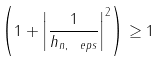<formula> <loc_0><loc_0><loc_500><loc_500>\left ( 1 + \left | \frac { 1 } { h _ { n , \ e p s } } \right | ^ { 2 } \right ) \geq 1</formula> 